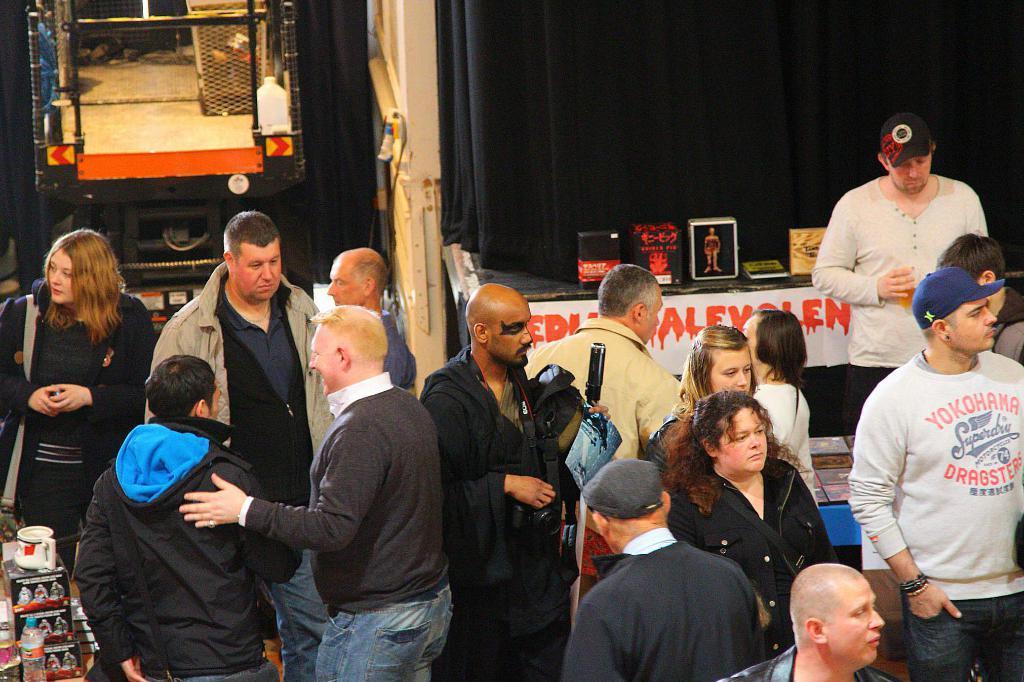Could you give a brief overview of what you see in this image? In the foreground, I can see a group of people on the floor and some objects. In the background, I can see curtains, some objects and metal objects. This picture might be taken in a day. 